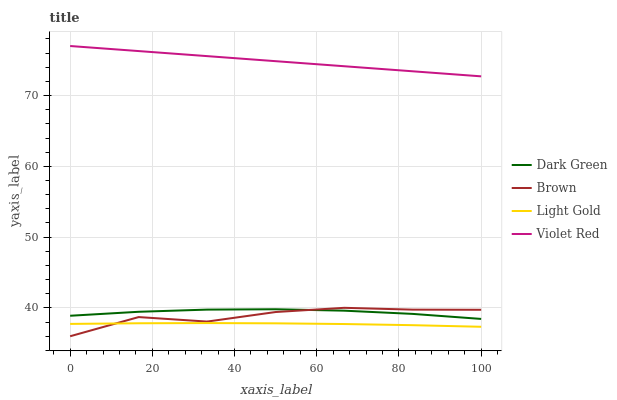Does Light Gold have the minimum area under the curve?
Answer yes or no. Yes. Does Violet Red have the maximum area under the curve?
Answer yes or no. Yes. Does Violet Red have the minimum area under the curve?
Answer yes or no. No. Does Light Gold have the maximum area under the curve?
Answer yes or no. No. Is Violet Red the smoothest?
Answer yes or no. Yes. Is Brown the roughest?
Answer yes or no. Yes. Is Light Gold the smoothest?
Answer yes or no. No. Is Light Gold the roughest?
Answer yes or no. No. Does Light Gold have the lowest value?
Answer yes or no. No. Does Violet Red have the highest value?
Answer yes or no. Yes. Does Light Gold have the highest value?
Answer yes or no. No. Is Light Gold less than Dark Green?
Answer yes or no. Yes. Is Dark Green greater than Light Gold?
Answer yes or no. Yes. Does Light Gold intersect Dark Green?
Answer yes or no. No. 